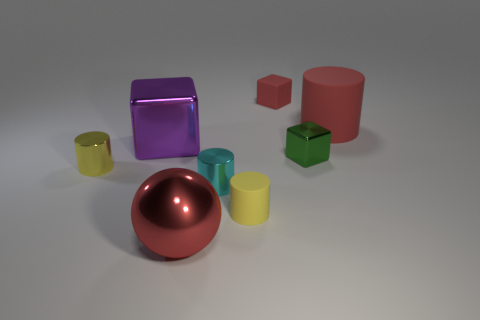What number of other objects are there of the same size as the ball?
Offer a terse response. 2. Are the red thing that is behind the large cylinder and the red object that is in front of the purple cube made of the same material?
Your response must be concise. No. What number of tiny red rubber blocks are behind the large red shiny object?
Provide a short and direct response. 1. How many red things are either tiny cubes or big cubes?
Your response must be concise. 1. There is a purple block that is the same size as the red cylinder; what material is it?
Offer a very short reply. Metal. There is a tiny object that is both to the right of the small rubber cylinder and in front of the red matte cylinder; what shape is it?
Give a very brief answer. Cube. There is a shiny thing that is the same size as the red metal sphere; what color is it?
Give a very brief answer. Purple. Do the shiny cylinder that is to the left of the large purple shiny block and the red object that is in front of the red matte cylinder have the same size?
Offer a terse response. No. What size is the rubber cylinder that is in front of the big shiny thing to the left of the large object in front of the cyan cylinder?
Provide a short and direct response. Small. There is a purple object left of the tiny block on the right side of the rubber cube; what is its shape?
Offer a terse response. Cube. 